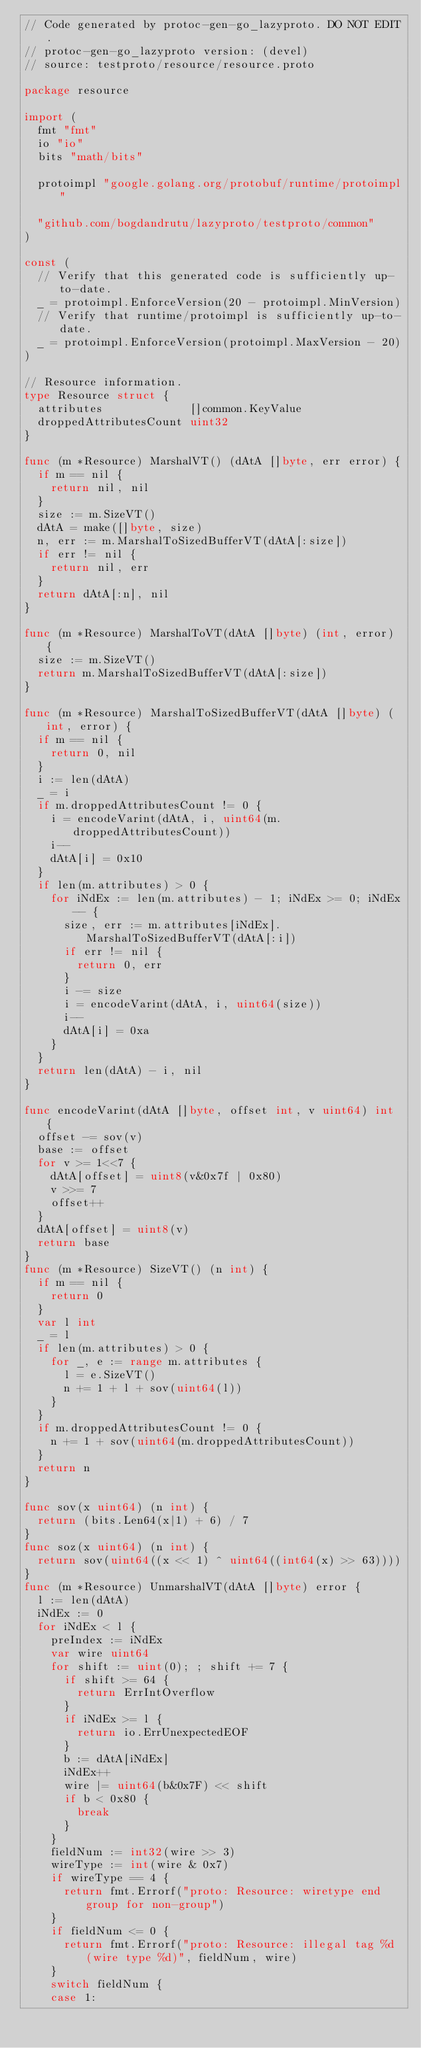Convert code to text. <code><loc_0><loc_0><loc_500><loc_500><_Go_>// Code generated by protoc-gen-go_lazyproto. DO NOT EDIT.
// protoc-gen-go_lazyproto version: (devel)
// source: testproto/resource/resource.proto

package resource

import (
	fmt "fmt"
	io "io"
	bits "math/bits"

	protoimpl "google.golang.org/protobuf/runtime/protoimpl"

	"github.com/bogdandrutu/lazyproto/testproto/common"
)

const (
	// Verify that this generated code is sufficiently up-to-date.
	_ = protoimpl.EnforceVersion(20 - protoimpl.MinVersion)
	// Verify that runtime/protoimpl is sufficiently up-to-date.
	_ = protoimpl.EnforceVersion(protoimpl.MaxVersion - 20)
)

// Resource information.
type Resource struct {
	attributes             []common.KeyValue
	droppedAttributesCount uint32
}

func (m *Resource) MarshalVT() (dAtA []byte, err error) {
	if m == nil {
		return nil, nil
	}
	size := m.SizeVT()
	dAtA = make([]byte, size)
	n, err := m.MarshalToSizedBufferVT(dAtA[:size])
	if err != nil {
		return nil, err
	}
	return dAtA[:n], nil
}

func (m *Resource) MarshalToVT(dAtA []byte) (int, error) {
	size := m.SizeVT()
	return m.MarshalToSizedBufferVT(dAtA[:size])
}

func (m *Resource) MarshalToSizedBufferVT(dAtA []byte) (int, error) {
	if m == nil {
		return 0, nil
	}
	i := len(dAtA)
	_ = i
	if m.droppedAttributesCount != 0 {
		i = encodeVarint(dAtA, i, uint64(m.droppedAttributesCount))
		i--
		dAtA[i] = 0x10
	}
	if len(m.attributes) > 0 {
		for iNdEx := len(m.attributes) - 1; iNdEx >= 0; iNdEx-- {
			size, err := m.attributes[iNdEx].MarshalToSizedBufferVT(dAtA[:i])
			if err != nil {
				return 0, err
			}
			i -= size
			i = encodeVarint(dAtA, i, uint64(size))
			i--
			dAtA[i] = 0xa
		}
	}
	return len(dAtA) - i, nil
}

func encodeVarint(dAtA []byte, offset int, v uint64) int {
	offset -= sov(v)
	base := offset
	for v >= 1<<7 {
		dAtA[offset] = uint8(v&0x7f | 0x80)
		v >>= 7
		offset++
	}
	dAtA[offset] = uint8(v)
	return base
}
func (m *Resource) SizeVT() (n int) {
	if m == nil {
		return 0
	}
	var l int
	_ = l
	if len(m.attributes) > 0 {
		for _, e := range m.attributes {
			l = e.SizeVT()
			n += 1 + l + sov(uint64(l))
		}
	}
	if m.droppedAttributesCount != 0 {
		n += 1 + sov(uint64(m.droppedAttributesCount))
	}
	return n
}

func sov(x uint64) (n int) {
	return (bits.Len64(x|1) + 6) / 7
}
func soz(x uint64) (n int) {
	return sov(uint64((x << 1) ^ uint64((int64(x) >> 63))))
}
func (m *Resource) UnmarshalVT(dAtA []byte) error {
	l := len(dAtA)
	iNdEx := 0
	for iNdEx < l {
		preIndex := iNdEx
		var wire uint64
		for shift := uint(0); ; shift += 7 {
			if shift >= 64 {
				return ErrIntOverflow
			}
			if iNdEx >= l {
				return io.ErrUnexpectedEOF
			}
			b := dAtA[iNdEx]
			iNdEx++
			wire |= uint64(b&0x7F) << shift
			if b < 0x80 {
				break
			}
		}
		fieldNum := int32(wire >> 3)
		wireType := int(wire & 0x7)
		if wireType == 4 {
			return fmt.Errorf("proto: Resource: wiretype end group for non-group")
		}
		if fieldNum <= 0 {
			return fmt.Errorf("proto: Resource: illegal tag %d (wire type %d)", fieldNum, wire)
		}
		switch fieldNum {
		case 1:</code> 